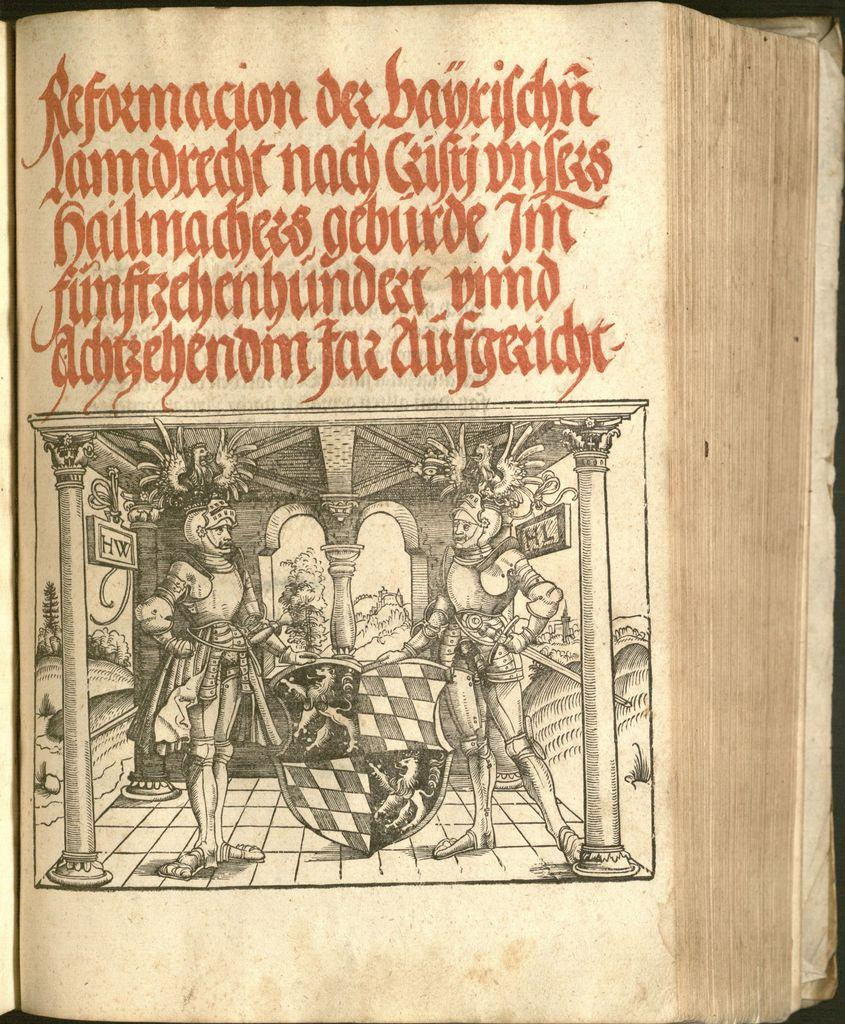What object is present in the image? There is a book in the image. What is depicted on the book? The book has a picture of two persons standing in front of each other. Is there any text associated with the picture? Yes, there is text written above the picture. How much blood is visible on the book in the image? There is no blood visible on the book in the image. Is there a brother standing next to the person in the image? The image on the book shows two persons standing in front of each other, but there is no indication of a familial relationship between them. 